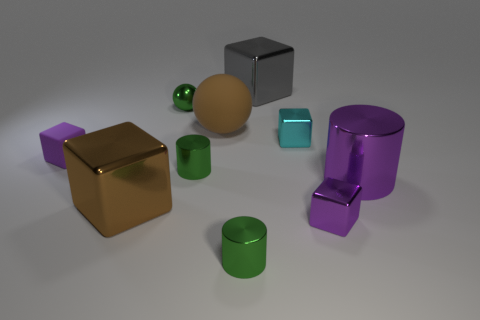Is the green cylinder left of the brown ball made of the same material as the brown block in front of the green metallic sphere?
Make the answer very short. Yes. What number of metallic things are big red blocks or purple things?
Ensure brevity in your answer.  2. What material is the green object that is in front of the green cylinder to the left of the sphere that is to the right of the small green metallic sphere made of?
Make the answer very short. Metal. There is a purple metal thing in front of the large brown metallic thing; is it the same shape as the big shiny object that is behind the green ball?
Offer a terse response. Yes. There is a tiny cylinder that is behind the metallic thing left of the tiny green metal ball; what color is it?
Provide a succinct answer. Green. How many cylinders are either cyan shiny things or large brown matte objects?
Provide a short and direct response. 0. What number of green shiny balls are in front of the large shiny thing that is on the left side of the gray thing behind the small purple rubber object?
Make the answer very short. 0. What is the size of the matte cube that is the same color as the big metallic cylinder?
Keep it short and to the point. Small. Is there a large purple cube made of the same material as the brown sphere?
Your answer should be compact. No. Do the large brown ball and the large purple cylinder have the same material?
Give a very brief answer. No. 